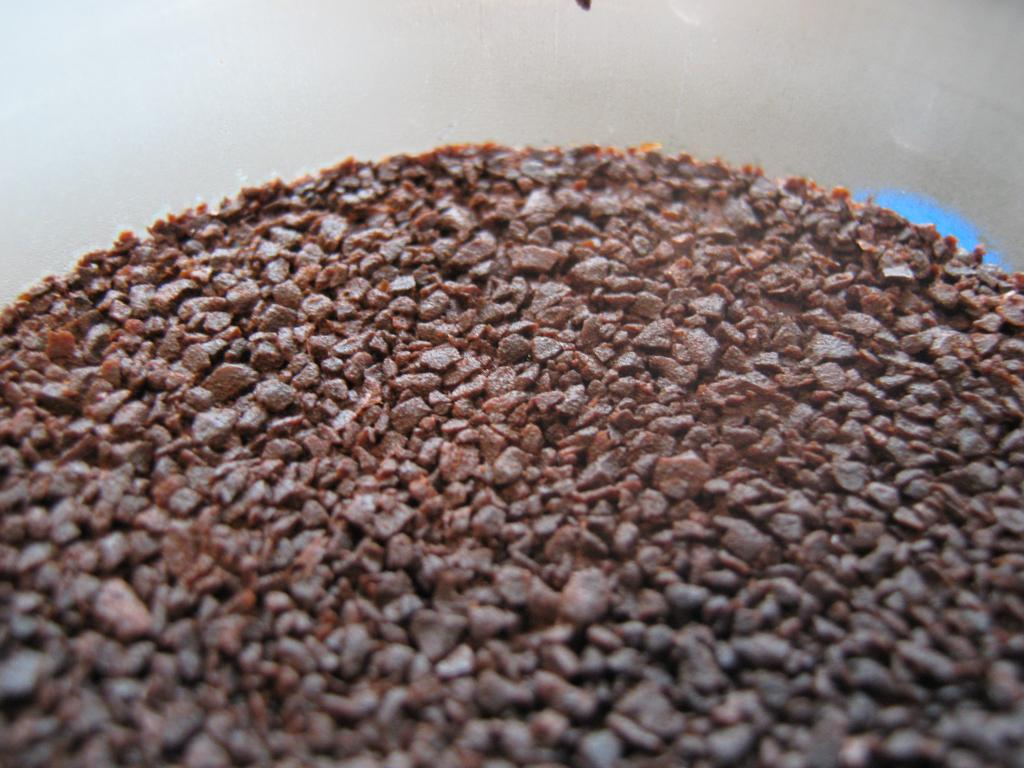What is in the bowl that is visible in the image? There are coffee crystals in the image. What type of container is holding the coffee crystals in the crystals? The coffee crystals are in a bowl. What theory is being proposed by the coffee crystals in the image? The coffee crystals in the image are not proposing any theories, as they are inanimate objects. 